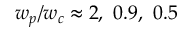<formula> <loc_0><loc_0><loc_500><loc_500>w _ { p } / w _ { c } \approx 2 , \ 0 . 9 , \ 0 . 5</formula> 